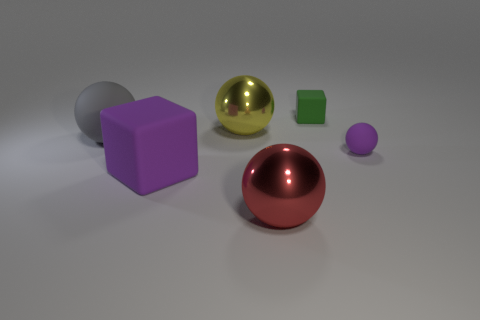Does the thing behind the big yellow shiny sphere have the same material as the purple object that is on the left side of the purple sphere?
Your response must be concise. Yes. What is the shape of the big red object?
Offer a terse response. Sphere. Is the number of purple rubber blocks that are behind the large matte block greater than the number of tiny purple rubber things left of the big gray rubber ball?
Make the answer very short. No. There is a rubber thing to the right of the green rubber cube; is it the same shape as the purple thing on the left side of the green rubber block?
Ensure brevity in your answer.  No. How many other things are the same size as the red thing?
Ensure brevity in your answer.  3. The purple ball is what size?
Keep it short and to the point. Small. Is the material of the cube that is to the left of the tiny green matte object the same as the yellow sphere?
Offer a terse response. No. There is a tiny matte object that is the same shape as the big purple rubber object; what is its color?
Your response must be concise. Green. There is a matte cube left of the tiny matte block; does it have the same color as the tiny block?
Keep it short and to the point. No. There is a large yellow shiny thing; are there any metallic balls behind it?
Provide a succinct answer. No. 